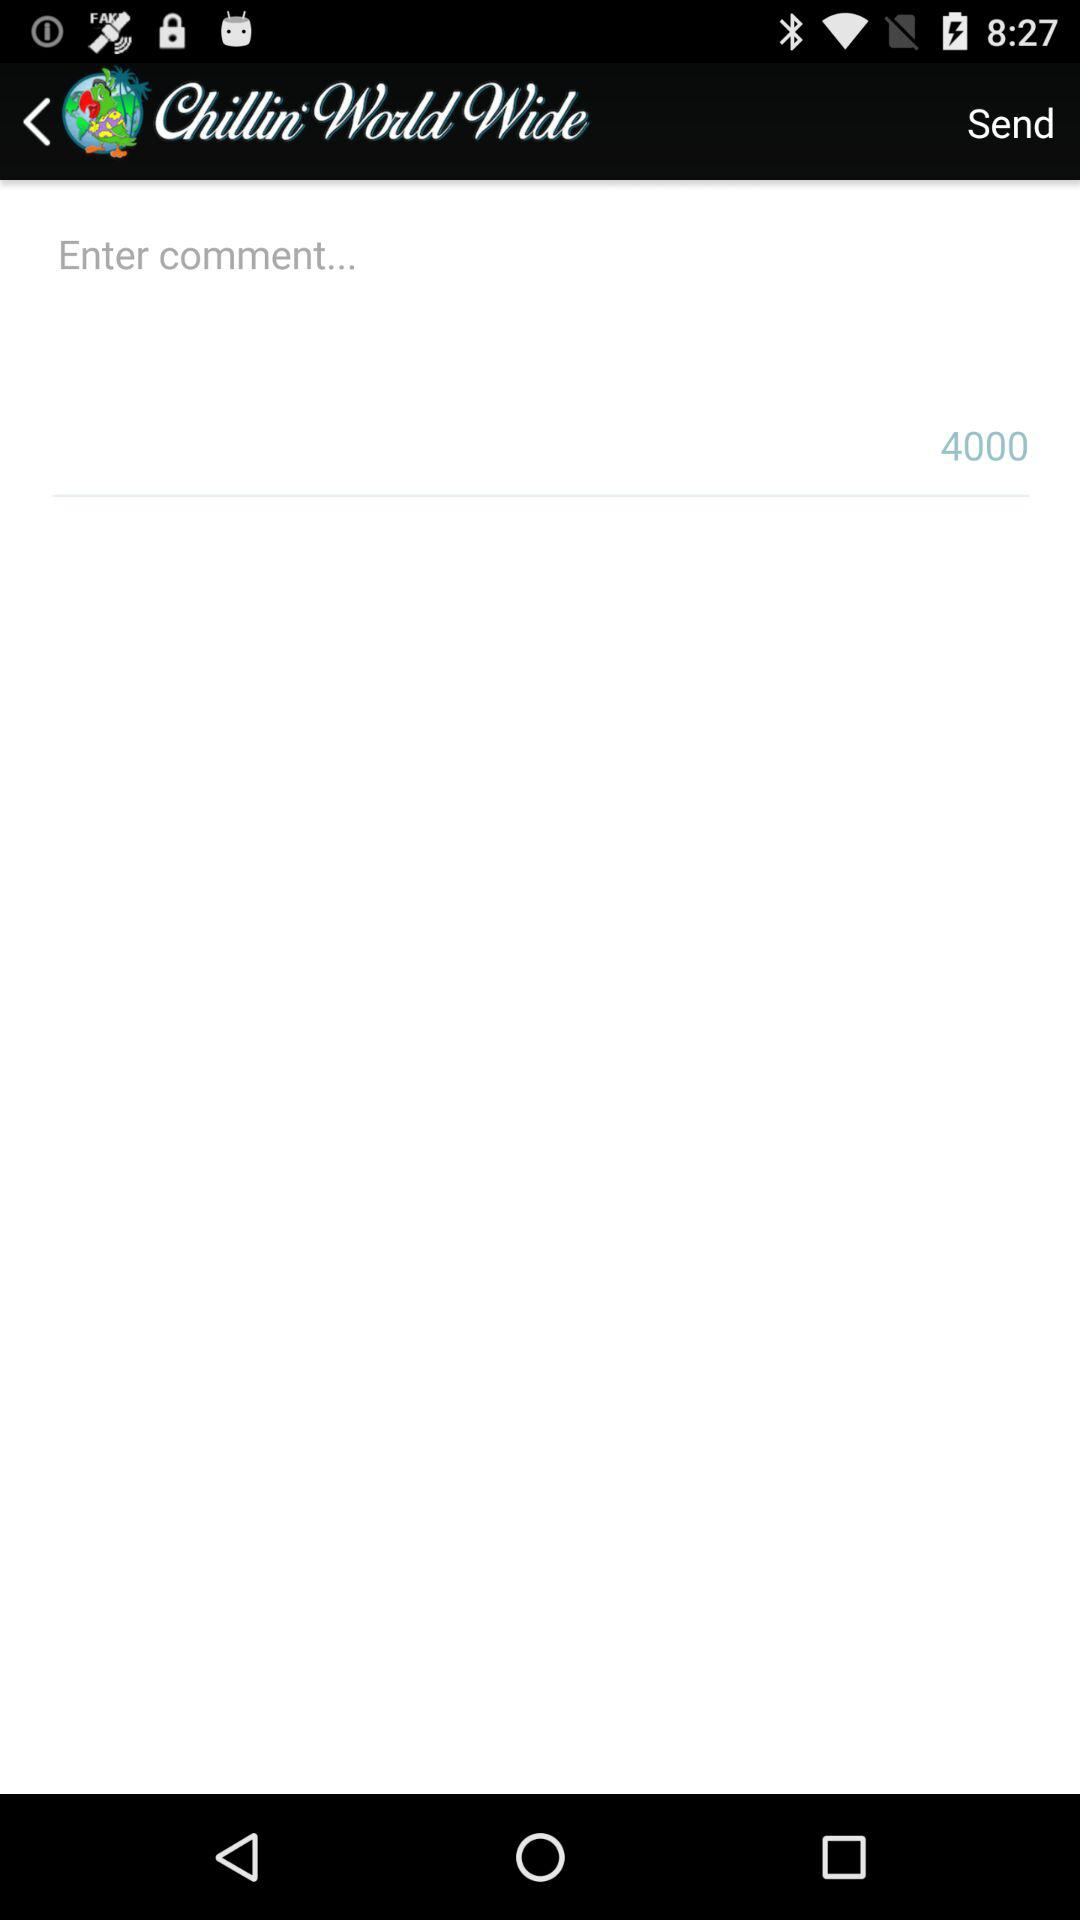What is the name of the application? The name of the application is "Chillin'WorldWide". 